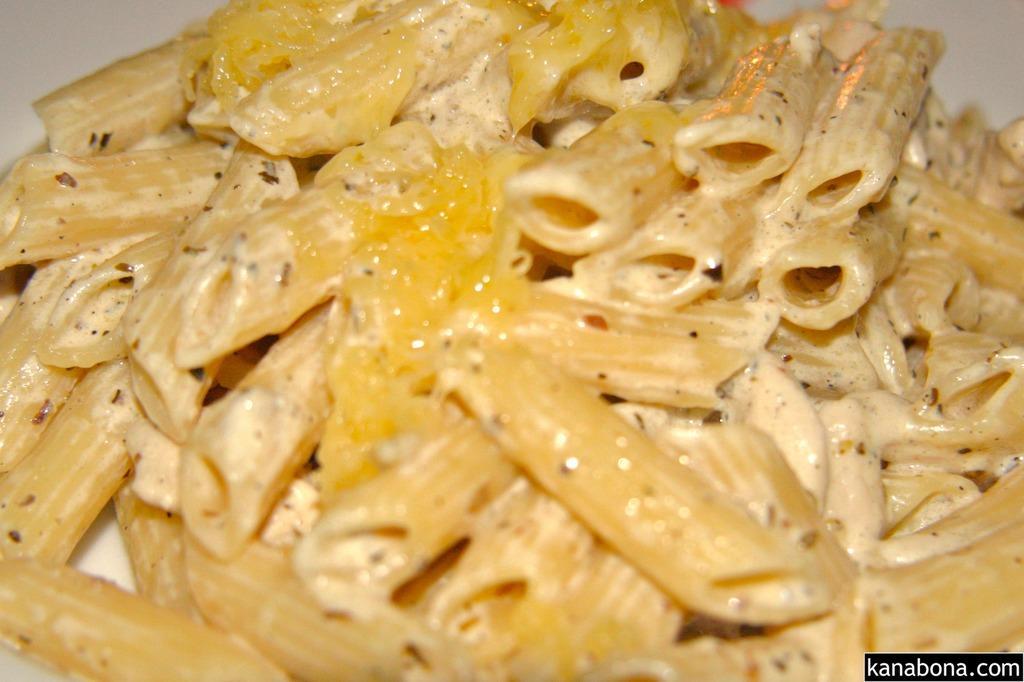Could you give a brief overview of what you see in this image? In this picture we can see pasta, at the right bottom there is some text. 